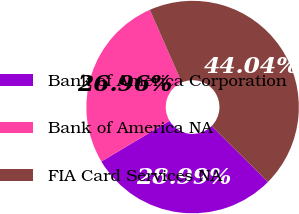Convert chart. <chart><loc_0><loc_0><loc_500><loc_500><pie_chart><fcel>Bank of America Corporation<fcel>Bank of America NA<fcel>FIA Card Services NA<nl><fcel>28.99%<fcel>26.96%<fcel>44.04%<nl></chart> 